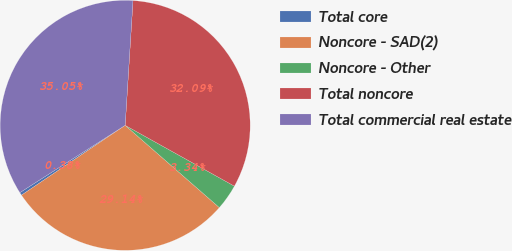<chart> <loc_0><loc_0><loc_500><loc_500><pie_chart><fcel>Total core<fcel>Noncore - SAD(2)<fcel>Noncore - Other<fcel>Total noncore<fcel>Total commercial real estate<nl><fcel>0.38%<fcel>29.14%<fcel>3.34%<fcel>32.09%<fcel>35.05%<nl></chart> 